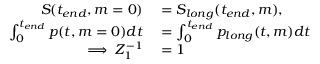<formula> <loc_0><loc_0><loc_500><loc_500>\begin{array} { r l } { S ( t _ { e n d } , m = 0 ) } & = S _ { l o n g } ( t _ { e n d } , m ) , } \\ { \int _ { 0 } ^ { t _ { e n d } } p ( t , m = 0 ) d t } & = \int _ { 0 } ^ { t _ { e n d } } p _ { l o n g } ( t , m ) d t } \\ { \implies Z _ { 1 } ^ { - 1 } } & = 1 } \end{array}</formula> 